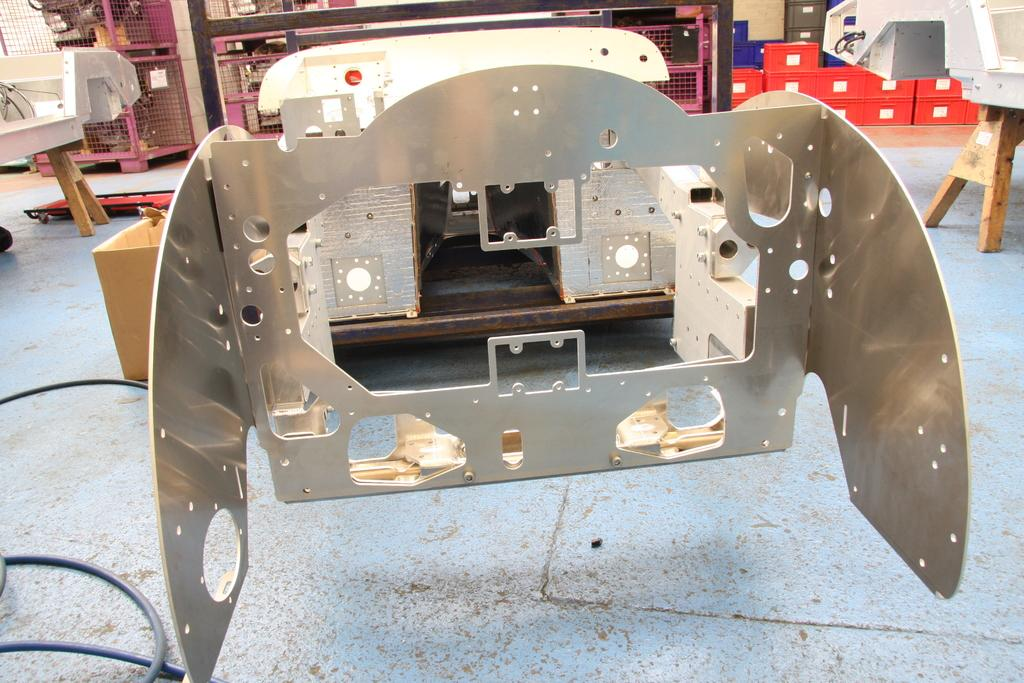What is located in the middle of the image? There are tables in the middle of the image. What can be seen on the tables? There are objects on the tables. What is visible behind the tables? There are boxes visible behind the tables. What type of iron is being used to extract the root in the image? There is no iron or root present in the image; it only features tables, objects on the tables, and boxes behind the tables. 